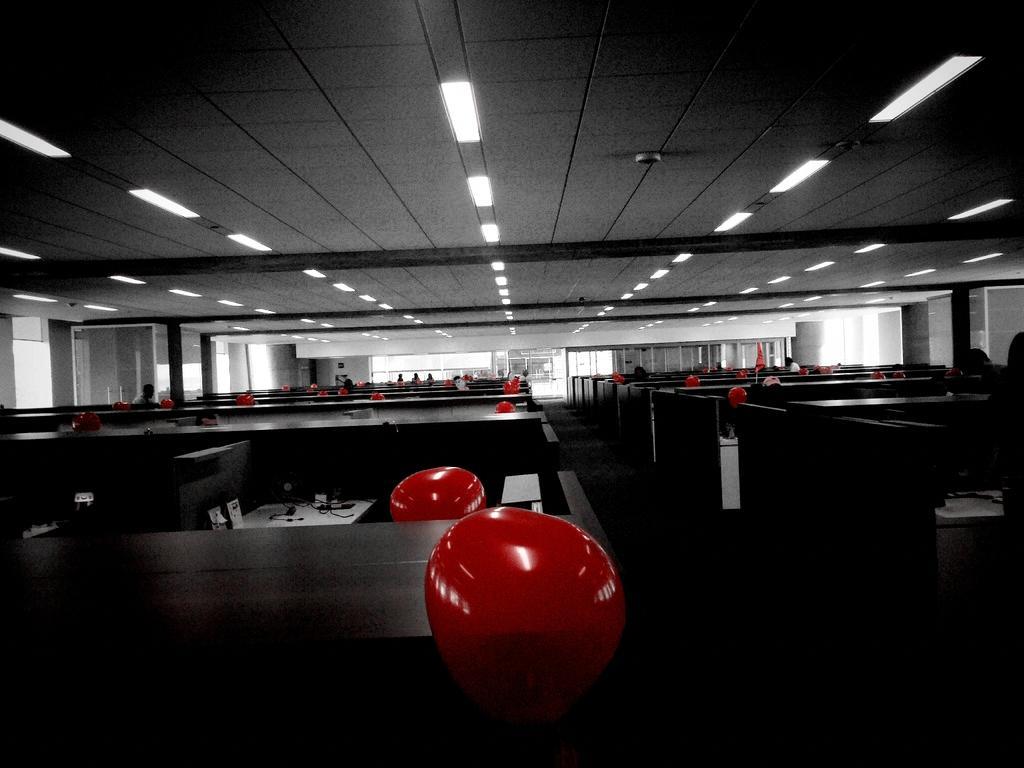Could you give a brief overview of what you see in this image? In this image we can see balloons, cabins, table, persons, lights, ceiling, windows and door. 